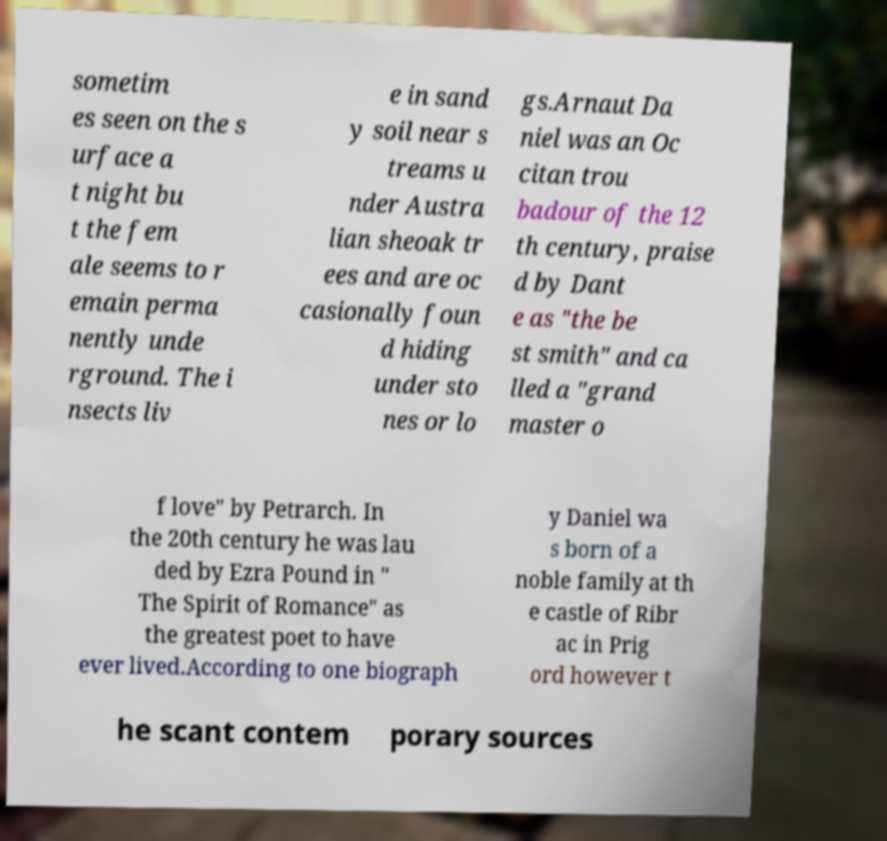Could you assist in decoding the text presented in this image and type it out clearly? sometim es seen on the s urface a t night bu t the fem ale seems to r emain perma nently unde rground. The i nsects liv e in sand y soil near s treams u nder Austra lian sheoak tr ees and are oc casionally foun d hiding under sto nes or lo gs.Arnaut Da niel was an Oc citan trou badour of the 12 th century, praise d by Dant e as "the be st smith" and ca lled a "grand master o f love" by Petrarch. In the 20th century he was lau ded by Ezra Pound in " The Spirit of Romance" as the greatest poet to have ever lived.According to one biograph y Daniel wa s born of a noble family at th e castle of Ribr ac in Prig ord however t he scant contem porary sources 